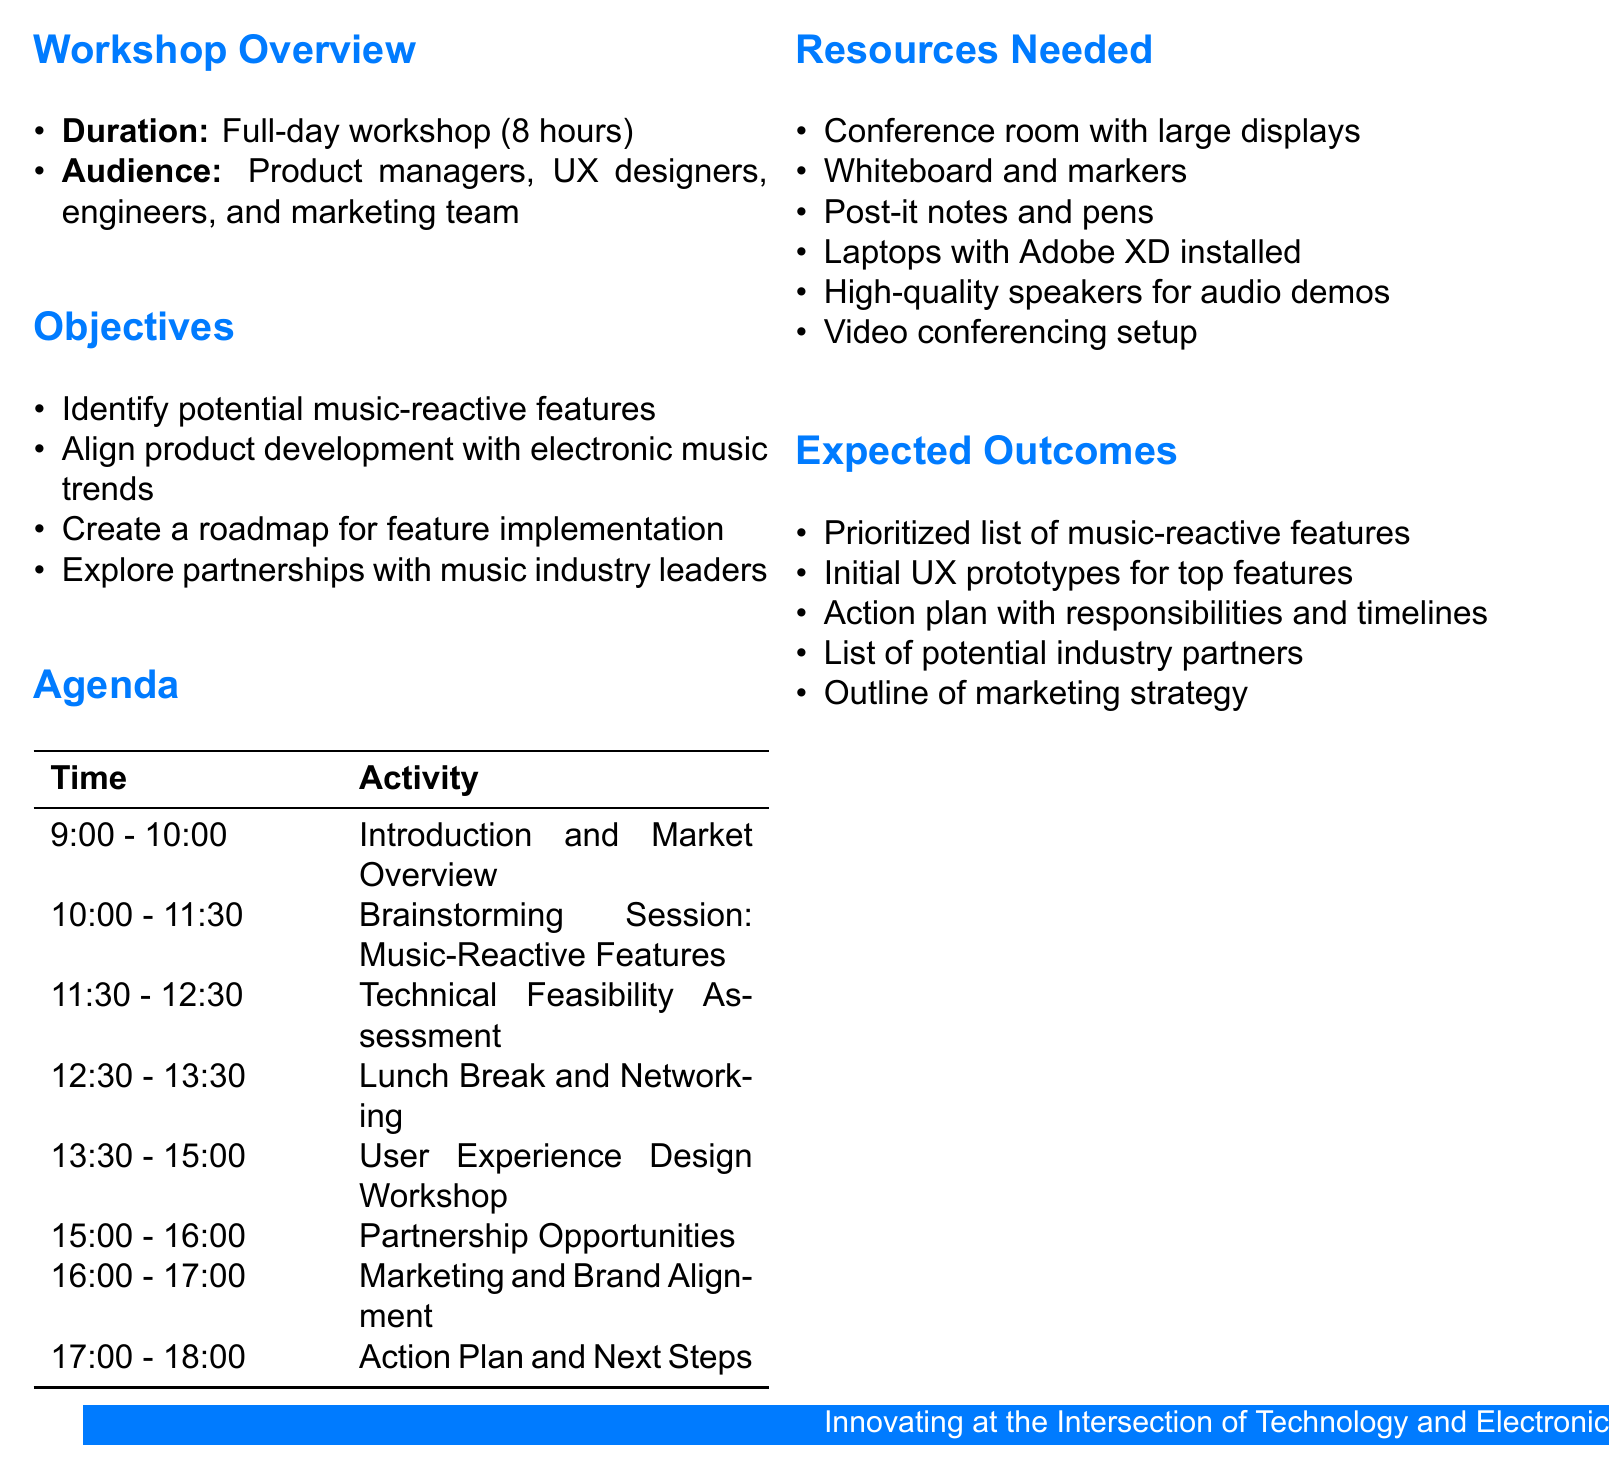What is the title of the workshop? The title of the workshop is stated in the document as "Integrating Music-Reactive Features into Our Flagship Product Line."
Answer: Integrating Music-Reactive Features into Our Flagship Product Line How long is the workshop scheduled to last? The duration of the workshop is specified in the overview as "Full-day workshop (8 hours)."
Answer: Full-day workshop (8 hours) Who is the target audience for the workshop? The target audience is outlined in the document to include "Product managers, UX designers, engineers, and marketing team."
Answer: Product managers, UX designers, engineers, and marketing team What is the first agenda item? The first agenda item is listed in the agenda table, which is "Introduction and Market Overview."
Answer: Introduction and Market Overview How long is the brainstorming session scheduled for? The duration of the brainstorming session is provided as "90 minutes."
Answer: 90 minutes What are the expected outcomes of the workshop? The expected outcomes section lists various goals, one of which is "Prioritized list of music-reactive features to implement."
Answer: Prioritized list of music-reactive features to implement Which team member is responsible for assessing technical feasibility? The document specifies that the "Chief Technology Officer" will present during the technical feasibility assessment.
Answer: Chief Technology Officer What session follows the lunch break? The agenda outlines that the session after the lunch break is the "User Experience Design Workshop."
Answer: User Experience Design Workshop 